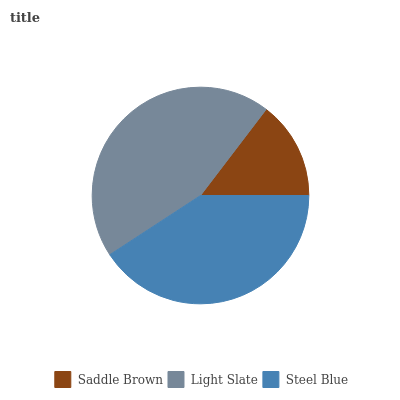Is Saddle Brown the minimum?
Answer yes or no. Yes. Is Light Slate the maximum?
Answer yes or no. Yes. Is Steel Blue the minimum?
Answer yes or no. No. Is Steel Blue the maximum?
Answer yes or no. No. Is Light Slate greater than Steel Blue?
Answer yes or no. Yes. Is Steel Blue less than Light Slate?
Answer yes or no. Yes. Is Steel Blue greater than Light Slate?
Answer yes or no. No. Is Light Slate less than Steel Blue?
Answer yes or no. No. Is Steel Blue the high median?
Answer yes or no. Yes. Is Steel Blue the low median?
Answer yes or no. Yes. Is Saddle Brown the high median?
Answer yes or no. No. Is Light Slate the low median?
Answer yes or no. No. 